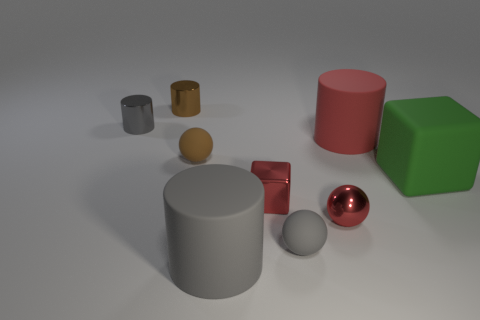Can you name all the different shapes you see in the image? Certainly! There are cylinders (both large and small), a sphere, a cube, and what appears to be a smaller, flatter circle or disc, potentially a hemisphere or truncated sphere, visible in the image. 